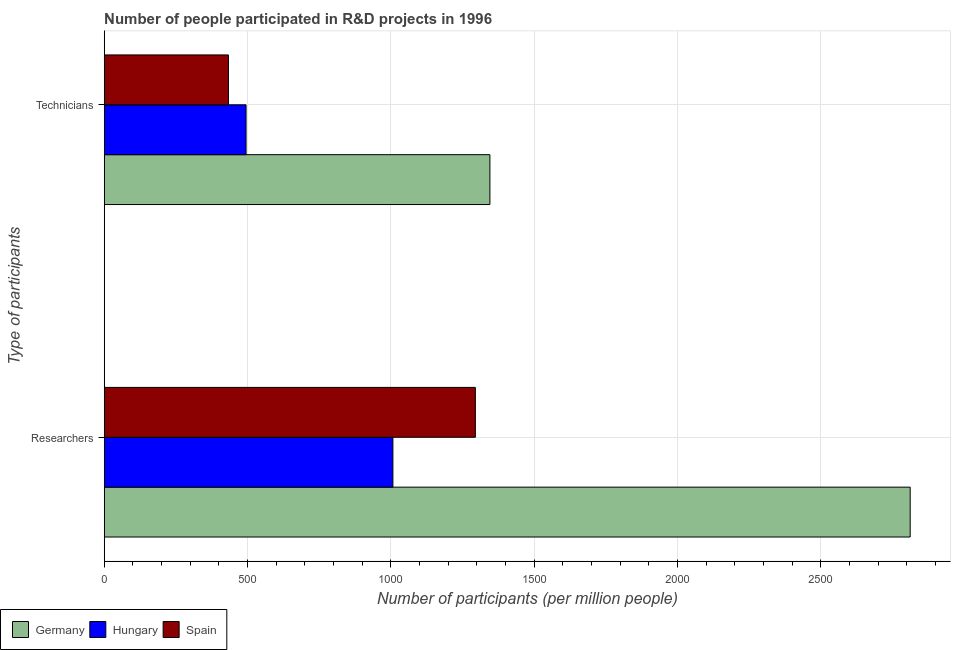How many different coloured bars are there?
Your answer should be compact. 3. How many groups of bars are there?
Your answer should be compact. 2. Are the number of bars per tick equal to the number of legend labels?
Offer a very short reply. Yes. What is the label of the 1st group of bars from the top?
Give a very brief answer. Technicians. What is the number of researchers in Spain?
Give a very brief answer. 1294.75. Across all countries, what is the maximum number of technicians?
Make the answer very short. 1345.46. Across all countries, what is the minimum number of researchers?
Provide a succinct answer. 1007.08. In which country was the number of technicians minimum?
Provide a succinct answer. Spain. What is the total number of researchers in the graph?
Offer a very short reply. 5113.43. What is the difference between the number of researchers in Germany and that in Hungary?
Give a very brief answer. 1804.54. What is the difference between the number of researchers in Spain and the number of technicians in Germany?
Your answer should be very brief. -50.72. What is the average number of technicians per country?
Provide a succinct answer. 757.88. What is the difference between the number of technicians and number of researchers in Spain?
Keep it short and to the point. -861.41. What is the ratio of the number of researchers in Germany to that in Spain?
Offer a terse response. 2.17. What does the 3rd bar from the top in Researchers represents?
Your response must be concise. Germany. Are all the bars in the graph horizontal?
Your answer should be compact. Yes. How many countries are there in the graph?
Offer a terse response. 3. What is the difference between two consecutive major ticks on the X-axis?
Give a very brief answer. 500. Does the graph contain any zero values?
Offer a very short reply. No. Where does the legend appear in the graph?
Your answer should be compact. Bottom left. How many legend labels are there?
Your answer should be compact. 3. How are the legend labels stacked?
Your answer should be very brief. Horizontal. What is the title of the graph?
Ensure brevity in your answer.  Number of people participated in R&D projects in 1996. What is the label or title of the X-axis?
Your response must be concise. Number of participants (per million people). What is the label or title of the Y-axis?
Ensure brevity in your answer.  Type of participants. What is the Number of participants (per million people) in Germany in Researchers?
Keep it short and to the point. 2811.61. What is the Number of participants (per million people) in Hungary in Researchers?
Offer a very short reply. 1007.08. What is the Number of participants (per million people) of Spain in Researchers?
Provide a succinct answer. 1294.75. What is the Number of participants (per million people) of Germany in Technicians?
Your response must be concise. 1345.46. What is the Number of participants (per million people) of Hungary in Technicians?
Provide a succinct answer. 494.83. What is the Number of participants (per million people) of Spain in Technicians?
Your answer should be compact. 433.34. Across all Type of participants, what is the maximum Number of participants (per million people) in Germany?
Offer a terse response. 2811.61. Across all Type of participants, what is the maximum Number of participants (per million people) in Hungary?
Provide a short and direct response. 1007.08. Across all Type of participants, what is the maximum Number of participants (per million people) of Spain?
Keep it short and to the point. 1294.75. Across all Type of participants, what is the minimum Number of participants (per million people) of Germany?
Provide a succinct answer. 1345.46. Across all Type of participants, what is the minimum Number of participants (per million people) in Hungary?
Give a very brief answer. 494.83. Across all Type of participants, what is the minimum Number of participants (per million people) of Spain?
Provide a succinct answer. 433.34. What is the total Number of participants (per million people) in Germany in the graph?
Make the answer very short. 4157.08. What is the total Number of participants (per million people) in Hungary in the graph?
Your answer should be very brief. 1501.9. What is the total Number of participants (per million people) of Spain in the graph?
Offer a terse response. 1728.08. What is the difference between the Number of participants (per million people) in Germany in Researchers and that in Technicians?
Provide a succinct answer. 1466.15. What is the difference between the Number of participants (per million people) of Hungary in Researchers and that in Technicians?
Offer a very short reply. 512.25. What is the difference between the Number of participants (per million people) in Spain in Researchers and that in Technicians?
Offer a terse response. 861.41. What is the difference between the Number of participants (per million people) in Germany in Researchers and the Number of participants (per million people) in Hungary in Technicians?
Provide a short and direct response. 2316.78. What is the difference between the Number of participants (per million people) of Germany in Researchers and the Number of participants (per million people) of Spain in Technicians?
Provide a succinct answer. 2378.28. What is the difference between the Number of participants (per million people) in Hungary in Researchers and the Number of participants (per million people) in Spain in Technicians?
Offer a terse response. 573.74. What is the average Number of participants (per million people) of Germany per Type of participants?
Give a very brief answer. 2078.54. What is the average Number of participants (per million people) in Hungary per Type of participants?
Ensure brevity in your answer.  750.95. What is the average Number of participants (per million people) in Spain per Type of participants?
Your response must be concise. 864.04. What is the difference between the Number of participants (per million people) of Germany and Number of participants (per million people) of Hungary in Researchers?
Your response must be concise. 1804.54. What is the difference between the Number of participants (per million people) of Germany and Number of participants (per million people) of Spain in Researchers?
Provide a short and direct response. 1516.87. What is the difference between the Number of participants (per million people) of Hungary and Number of participants (per million people) of Spain in Researchers?
Ensure brevity in your answer.  -287.67. What is the difference between the Number of participants (per million people) in Germany and Number of participants (per million people) in Hungary in Technicians?
Offer a very short reply. 850.63. What is the difference between the Number of participants (per million people) of Germany and Number of participants (per million people) of Spain in Technicians?
Ensure brevity in your answer.  912.12. What is the difference between the Number of participants (per million people) in Hungary and Number of participants (per million people) in Spain in Technicians?
Keep it short and to the point. 61.49. What is the ratio of the Number of participants (per million people) in Germany in Researchers to that in Technicians?
Ensure brevity in your answer.  2.09. What is the ratio of the Number of participants (per million people) in Hungary in Researchers to that in Technicians?
Ensure brevity in your answer.  2.04. What is the ratio of the Number of participants (per million people) in Spain in Researchers to that in Technicians?
Keep it short and to the point. 2.99. What is the difference between the highest and the second highest Number of participants (per million people) in Germany?
Your answer should be compact. 1466.15. What is the difference between the highest and the second highest Number of participants (per million people) of Hungary?
Your response must be concise. 512.25. What is the difference between the highest and the second highest Number of participants (per million people) of Spain?
Offer a very short reply. 861.41. What is the difference between the highest and the lowest Number of participants (per million people) in Germany?
Provide a succinct answer. 1466.15. What is the difference between the highest and the lowest Number of participants (per million people) in Hungary?
Offer a very short reply. 512.25. What is the difference between the highest and the lowest Number of participants (per million people) in Spain?
Provide a succinct answer. 861.41. 